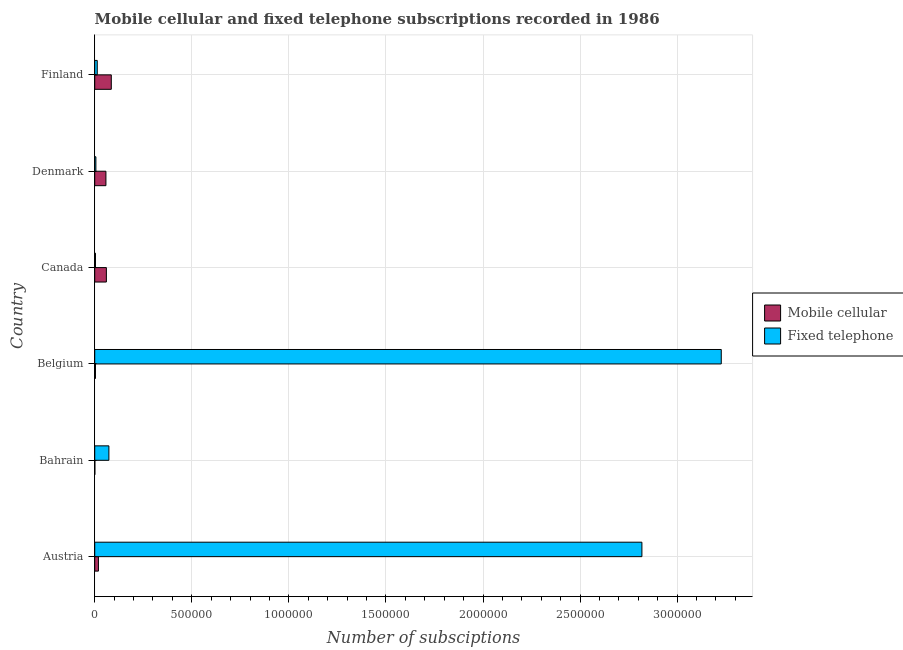Are the number of bars on each tick of the Y-axis equal?
Ensure brevity in your answer.  Yes. What is the label of the 4th group of bars from the top?
Make the answer very short. Belgium. In how many cases, is the number of bars for a given country not equal to the number of legend labels?
Ensure brevity in your answer.  0. What is the number of fixed telephone subscriptions in Denmark?
Your answer should be very brief. 6000. Across all countries, what is the maximum number of fixed telephone subscriptions?
Ensure brevity in your answer.  3.23e+06. Across all countries, what is the minimum number of mobile cellular subscriptions?
Keep it short and to the point. 618. In which country was the number of fixed telephone subscriptions maximum?
Provide a short and direct response. Belgium. In which country was the number of mobile cellular subscriptions minimum?
Keep it short and to the point. Bahrain. What is the total number of fixed telephone subscriptions in the graph?
Provide a short and direct response. 6.14e+06. What is the difference between the number of fixed telephone subscriptions in Austria and that in Bahrain?
Offer a terse response. 2.75e+06. What is the difference between the number of mobile cellular subscriptions in Austria and the number of fixed telephone subscriptions in Belgium?
Offer a terse response. -3.21e+06. What is the average number of fixed telephone subscriptions per country?
Make the answer very short. 1.02e+06. What is the difference between the number of mobile cellular subscriptions and number of fixed telephone subscriptions in Denmark?
Your response must be concise. 5.16e+04. In how many countries, is the number of mobile cellular subscriptions greater than 1600000 ?
Make the answer very short. 0. What is the ratio of the number of fixed telephone subscriptions in Bahrain to that in Finland?
Provide a succinct answer. 5.61. Is the number of fixed telephone subscriptions in Austria less than that in Bahrain?
Offer a very short reply. No. Is the difference between the number of mobile cellular subscriptions in Belgium and Canada greater than the difference between the number of fixed telephone subscriptions in Belgium and Canada?
Give a very brief answer. No. What is the difference between the highest and the second highest number of mobile cellular subscriptions?
Keep it short and to the point. 2.53e+04. What is the difference between the highest and the lowest number of fixed telephone subscriptions?
Give a very brief answer. 3.22e+06. In how many countries, is the number of mobile cellular subscriptions greater than the average number of mobile cellular subscriptions taken over all countries?
Keep it short and to the point. 3. Is the sum of the number of fixed telephone subscriptions in Denmark and Finland greater than the maximum number of mobile cellular subscriptions across all countries?
Your answer should be compact. No. What does the 2nd bar from the top in Bahrain represents?
Make the answer very short. Mobile cellular. What does the 2nd bar from the bottom in Bahrain represents?
Your response must be concise. Fixed telephone. Are all the bars in the graph horizontal?
Offer a very short reply. Yes. How many countries are there in the graph?
Your response must be concise. 6. Does the graph contain grids?
Offer a terse response. Yes. How many legend labels are there?
Keep it short and to the point. 2. How are the legend labels stacked?
Make the answer very short. Vertical. What is the title of the graph?
Give a very brief answer. Mobile cellular and fixed telephone subscriptions recorded in 1986. Does "Secondary Education" appear as one of the legend labels in the graph?
Ensure brevity in your answer.  No. What is the label or title of the X-axis?
Your answer should be compact. Number of subsciptions. What is the Number of subsciptions in Mobile cellular in Austria?
Provide a succinct answer. 1.91e+04. What is the Number of subsciptions of Fixed telephone in Austria?
Offer a very short reply. 2.82e+06. What is the Number of subsciptions in Mobile cellular in Bahrain?
Ensure brevity in your answer.  618. What is the Number of subsciptions in Fixed telephone in Bahrain?
Your answer should be compact. 7.29e+04. What is the Number of subsciptions of Mobile cellular in Belgium?
Offer a very short reply. 3798. What is the Number of subsciptions in Fixed telephone in Belgium?
Ensure brevity in your answer.  3.23e+06. What is the Number of subsciptions in Mobile cellular in Canada?
Your answer should be compact. 6.00e+04. What is the Number of subsciptions of Fixed telephone in Canada?
Offer a very short reply. 3902. What is the Number of subsciptions in Mobile cellular in Denmark?
Provide a succinct answer. 5.76e+04. What is the Number of subsciptions in Fixed telephone in Denmark?
Ensure brevity in your answer.  6000. What is the Number of subsciptions in Mobile cellular in Finland?
Offer a terse response. 8.53e+04. What is the Number of subsciptions in Fixed telephone in Finland?
Give a very brief answer. 1.30e+04. Across all countries, what is the maximum Number of subsciptions in Mobile cellular?
Give a very brief answer. 8.53e+04. Across all countries, what is the maximum Number of subsciptions of Fixed telephone?
Offer a very short reply. 3.23e+06. Across all countries, what is the minimum Number of subsciptions of Mobile cellular?
Offer a very short reply. 618. Across all countries, what is the minimum Number of subsciptions in Fixed telephone?
Your response must be concise. 3902. What is the total Number of subsciptions in Mobile cellular in the graph?
Offer a terse response. 2.26e+05. What is the total Number of subsciptions of Fixed telephone in the graph?
Make the answer very short. 6.14e+06. What is the difference between the Number of subsciptions in Mobile cellular in Austria and that in Bahrain?
Your answer should be very brief. 1.85e+04. What is the difference between the Number of subsciptions in Fixed telephone in Austria and that in Bahrain?
Provide a succinct answer. 2.75e+06. What is the difference between the Number of subsciptions of Mobile cellular in Austria and that in Belgium?
Your response must be concise. 1.53e+04. What is the difference between the Number of subsciptions in Fixed telephone in Austria and that in Belgium?
Provide a succinct answer. -4.09e+05. What is the difference between the Number of subsciptions in Mobile cellular in Austria and that in Canada?
Keep it short and to the point. -4.09e+04. What is the difference between the Number of subsciptions of Fixed telephone in Austria and that in Canada?
Give a very brief answer. 2.81e+06. What is the difference between the Number of subsciptions in Mobile cellular in Austria and that in Denmark?
Offer a terse response. -3.85e+04. What is the difference between the Number of subsciptions in Fixed telephone in Austria and that in Denmark?
Offer a very short reply. 2.81e+06. What is the difference between the Number of subsciptions in Mobile cellular in Austria and that in Finland?
Your answer should be compact. -6.62e+04. What is the difference between the Number of subsciptions in Fixed telephone in Austria and that in Finland?
Make the answer very short. 2.81e+06. What is the difference between the Number of subsciptions of Mobile cellular in Bahrain and that in Belgium?
Your response must be concise. -3180. What is the difference between the Number of subsciptions of Fixed telephone in Bahrain and that in Belgium?
Your answer should be very brief. -3.15e+06. What is the difference between the Number of subsciptions in Mobile cellular in Bahrain and that in Canada?
Provide a short and direct response. -5.94e+04. What is the difference between the Number of subsciptions in Fixed telephone in Bahrain and that in Canada?
Ensure brevity in your answer.  6.90e+04. What is the difference between the Number of subsciptions in Mobile cellular in Bahrain and that in Denmark?
Your response must be concise. -5.70e+04. What is the difference between the Number of subsciptions of Fixed telephone in Bahrain and that in Denmark?
Give a very brief answer. 6.69e+04. What is the difference between the Number of subsciptions of Mobile cellular in Bahrain and that in Finland?
Offer a very short reply. -8.47e+04. What is the difference between the Number of subsciptions in Fixed telephone in Bahrain and that in Finland?
Make the answer very short. 5.99e+04. What is the difference between the Number of subsciptions of Mobile cellular in Belgium and that in Canada?
Offer a terse response. -5.62e+04. What is the difference between the Number of subsciptions in Fixed telephone in Belgium and that in Canada?
Ensure brevity in your answer.  3.22e+06. What is the difference between the Number of subsciptions of Mobile cellular in Belgium and that in Denmark?
Give a very brief answer. -5.38e+04. What is the difference between the Number of subsciptions in Fixed telephone in Belgium and that in Denmark?
Provide a succinct answer. 3.22e+06. What is the difference between the Number of subsciptions in Mobile cellular in Belgium and that in Finland?
Your answer should be very brief. -8.15e+04. What is the difference between the Number of subsciptions in Fixed telephone in Belgium and that in Finland?
Keep it short and to the point. 3.21e+06. What is the difference between the Number of subsciptions of Mobile cellular in Canada and that in Denmark?
Your answer should be very brief. 2396. What is the difference between the Number of subsciptions of Fixed telephone in Canada and that in Denmark?
Your response must be concise. -2098. What is the difference between the Number of subsciptions in Mobile cellular in Canada and that in Finland?
Ensure brevity in your answer.  -2.53e+04. What is the difference between the Number of subsciptions in Fixed telephone in Canada and that in Finland?
Keep it short and to the point. -9098. What is the difference between the Number of subsciptions in Mobile cellular in Denmark and that in Finland?
Your response must be concise. -2.77e+04. What is the difference between the Number of subsciptions in Fixed telephone in Denmark and that in Finland?
Provide a succinct answer. -7000. What is the difference between the Number of subsciptions of Mobile cellular in Austria and the Number of subsciptions of Fixed telephone in Bahrain?
Make the answer very short. -5.38e+04. What is the difference between the Number of subsciptions of Mobile cellular in Austria and the Number of subsciptions of Fixed telephone in Belgium?
Your answer should be compact. -3.21e+06. What is the difference between the Number of subsciptions of Mobile cellular in Austria and the Number of subsciptions of Fixed telephone in Canada?
Offer a terse response. 1.52e+04. What is the difference between the Number of subsciptions of Mobile cellular in Austria and the Number of subsciptions of Fixed telephone in Denmark?
Your response must be concise. 1.31e+04. What is the difference between the Number of subsciptions of Mobile cellular in Austria and the Number of subsciptions of Fixed telephone in Finland?
Ensure brevity in your answer.  6104. What is the difference between the Number of subsciptions of Mobile cellular in Bahrain and the Number of subsciptions of Fixed telephone in Belgium?
Your response must be concise. -3.23e+06. What is the difference between the Number of subsciptions in Mobile cellular in Bahrain and the Number of subsciptions in Fixed telephone in Canada?
Offer a terse response. -3284. What is the difference between the Number of subsciptions of Mobile cellular in Bahrain and the Number of subsciptions of Fixed telephone in Denmark?
Keep it short and to the point. -5382. What is the difference between the Number of subsciptions of Mobile cellular in Bahrain and the Number of subsciptions of Fixed telephone in Finland?
Offer a very short reply. -1.24e+04. What is the difference between the Number of subsciptions in Mobile cellular in Belgium and the Number of subsciptions in Fixed telephone in Canada?
Keep it short and to the point. -104. What is the difference between the Number of subsciptions of Mobile cellular in Belgium and the Number of subsciptions of Fixed telephone in Denmark?
Ensure brevity in your answer.  -2202. What is the difference between the Number of subsciptions in Mobile cellular in Belgium and the Number of subsciptions in Fixed telephone in Finland?
Give a very brief answer. -9202. What is the difference between the Number of subsciptions in Mobile cellular in Canada and the Number of subsciptions in Fixed telephone in Denmark?
Provide a succinct answer. 5.40e+04. What is the difference between the Number of subsciptions in Mobile cellular in Canada and the Number of subsciptions in Fixed telephone in Finland?
Provide a succinct answer. 4.70e+04. What is the difference between the Number of subsciptions in Mobile cellular in Denmark and the Number of subsciptions in Fixed telephone in Finland?
Your response must be concise. 4.46e+04. What is the average Number of subsciptions of Mobile cellular per country?
Your answer should be compact. 3.77e+04. What is the average Number of subsciptions in Fixed telephone per country?
Offer a terse response. 1.02e+06. What is the difference between the Number of subsciptions of Mobile cellular and Number of subsciptions of Fixed telephone in Austria?
Provide a succinct answer. -2.80e+06. What is the difference between the Number of subsciptions in Mobile cellular and Number of subsciptions in Fixed telephone in Bahrain?
Give a very brief answer. -7.23e+04. What is the difference between the Number of subsciptions of Mobile cellular and Number of subsciptions of Fixed telephone in Belgium?
Offer a terse response. -3.22e+06. What is the difference between the Number of subsciptions in Mobile cellular and Number of subsciptions in Fixed telephone in Canada?
Provide a short and direct response. 5.61e+04. What is the difference between the Number of subsciptions of Mobile cellular and Number of subsciptions of Fixed telephone in Denmark?
Keep it short and to the point. 5.16e+04. What is the difference between the Number of subsciptions in Mobile cellular and Number of subsciptions in Fixed telephone in Finland?
Offer a very short reply. 7.23e+04. What is the ratio of the Number of subsciptions in Mobile cellular in Austria to that in Bahrain?
Your answer should be compact. 30.91. What is the ratio of the Number of subsciptions of Fixed telephone in Austria to that in Bahrain?
Offer a very short reply. 38.66. What is the ratio of the Number of subsciptions of Mobile cellular in Austria to that in Belgium?
Keep it short and to the point. 5.03. What is the ratio of the Number of subsciptions of Fixed telephone in Austria to that in Belgium?
Keep it short and to the point. 0.87. What is the ratio of the Number of subsciptions of Mobile cellular in Austria to that in Canada?
Offer a terse response. 0.32. What is the ratio of the Number of subsciptions in Fixed telephone in Austria to that in Canada?
Your answer should be very brief. 722.31. What is the ratio of the Number of subsciptions of Mobile cellular in Austria to that in Denmark?
Your answer should be very brief. 0.33. What is the ratio of the Number of subsciptions in Fixed telephone in Austria to that in Denmark?
Your answer should be very brief. 469.74. What is the ratio of the Number of subsciptions in Mobile cellular in Austria to that in Finland?
Your answer should be very brief. 0.22. What is the ratio of the Number of subsciptions of Fixed telephone in Austria to that in Finland?
Your answer should be very brief. 216.8. What is the ratio of the Number of subsciptions of Mobile cellular in Bahrain to that in Belgium?
Your answer should be compact. 0.16. What is the ratio of the Number of subsciptions in Fixed telephone in Bahrain to that in Belgium?
Make the answer very short. 0.02. What is the ratio of the Number of subsciptions of Mobile cellular in Bahrain to that in Canada?
Make the answer very short. 0.01. What is the ratio of the Number of subsciptions of Fixed telephone in Bahrain to that in Canada?
Your answer should be compact. 18.68. What is the ratio of the Number of subsciptions of Mobile cellular in Bahrain to that in Denmark?
Keep it short and to the point. 0.01. What is the ratio of the Number of subsciptions of Fixed telephone in Bahrain to that in Denmark?
Provide a short and direct response. 12.15. What is the ratio of the Number of subsciptions of Mobile cellular in Bahrain to that in Finland?
Ensure brevity in your answer.  0.01. What is the ratio of the Number of subsciptions in Fixed telephone in Bahrain to that in Finland?
Your answer should be compact. 5.61. What is the ratio of the Number of subsciptions in Mobile cellular in Belgium to that in Canada?
Ensure brevity in your answer.  0.06. What is the ratio of the Number of subsciptions in Fixed telephone in Belgium to that in Canada?
Your response must be concise. 827.05. What is the ratio of the Number of subsciptions of Mobile cellular in Belgium to that in Denmark?
Make the answer very short. 0.07. What is the ratio of the Number of subsciptions of Fixed telephone in Belgium to that in Denmark?
Provide a succinct answer. 537.86. What is the ratio of the Number of subsciptions of Mobile cellular in Belgium to that in Finland?
Provide a succinct answer. 0.04. What is the ratio of the Number of subsciptions of Fixed telephone in Belgium to that in Finland?
Provide a short and direct response. 248.24. What is the ratio of the Number of subsciptions in Mobile cellular in Canada to that in Denmark?
Offer a terse response. 1.04. What is the ratio of the Number of subsciptions of Fixed telephone in Canada to that in Denmark?
Offer a very short reply. 0.65. What is the ratio of the Number of subsciptions in Mobile cellular in Canada to that in Finland?
Give a very brief answer. 0.7. What is the ratio of the Number of subsciptions of Fixed telephone in Canada to that in Finland?
Provide a short and direct response. 0.3. What is the ratio of the Number of subsciptions in Mobile cellular in Denmark to that in Finland?
Make the answer very short. 0.68. What is the ratio of the Number of subsciptions in Fixed telephone in Denmark to that in Finland?
Provide a succinct answer. 0.46. What is the difference between the highest and the second highest Number of subsciptions of Mobile cellular?
Offer a terse response. 2.53e+04. What is the difference between the highest and the second highest Number of subsciptions in Fixed telephone?
Make the answer very short. 4.09e+05. What is the difference between the highest and the lowest Number of subsciptions of Mobile cellular?
Provide a succinct answer. 8.47e+04. What is the difference between the highest and the lowest Number of subsciptions in Fixed telephone?
Offer a very short reply. 3.22e+06. 